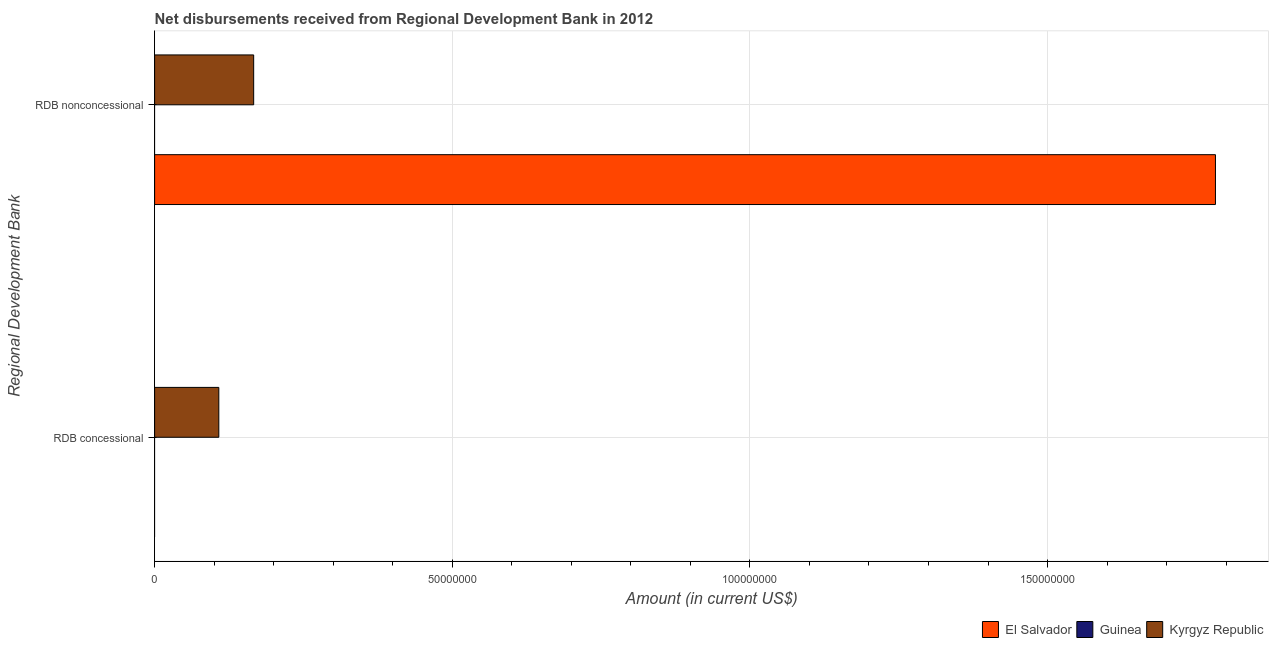How many different coloured bars are there?
Make the answer very short. 2. How many bars are there on the 1st tick from the bottom?
Offer a terse response. 1. What is the label of the 1st group of bars from the top?
Offer a very short reply. RDB nonconcessional. What is the net concessional disbursements from rdb in Kyrgyz Republic?
Ensure brevity in your answer.  1.08e+07. Across all countries, what is the maximum net concessional disbursements from rdb?
Offer a terse response. 1.08e+07. Across all countries, what is the minimum net non concessional disbursements from rdb?
Provide a succinct answer. 0. In which country was the net concessional disbursements from rdb maximum?
Offer a very short reply. Kyrgyz Republic. What is the total net concessional disbursements from rdb in the graph?
Your answer should be compact. 1.08e+07. What is the difference between the net non concessional disbursements from rdb in Kyrgyz Republic and that in El Salvador?
Keep it short and to the point. -1.62e+08. What is the difference between the net concessional disbursements from rdb in Kyrgyz Republic and the net non concessional disbursements from rdb in Guinea?
Keep it short and to the point. 1.08e+07. What is the average net concessional disbursements from rdb per country?
Make the answer very short. 3.60e+06. What is the difference between the net concessional disbursements from rdb and net non concessional disbursements from rdb in Kyrgyz Republic?
Offer a terse response. -5.86e+06. In how many countries, is the net concessional disbursements from rdb greater than 40000000 US$?
Provide a succinct answer. 0. What is the ratio of the net non concessional disbursements from rdb in Kyrgyz Republic to that in El Salvador?
Ensure brevity in your answer.  0.09. How many countries are there in the graph?
Your response must be concise. 3. Are the values on the major ticks of X-axis written in scientific E-notation?
Give a very brief answer. No. How many legend labels are there?
Your answer should be very brief. 3. What is the title of the graph?
Provide a short and direct response. Net disbursements received from Regional Development Bank in 2012. What is the label or title of the X-axis?
Ensure brevity in your answer.  Amount (in current US$). What is the label or title of the Y-axis?
Offer a very short reply. Regional Development Bank. What is the Amount (in current US$) in El Salvador in RDB concessional?
Keep it short and to the point. 0. What is the Amount (in current US$) in Kyrgyz Republic in RDB concessional?
Your answer should be very brief. 1.08e+07. What is the Amount (in current US$) in El Salvador in RDB nonconcessional?
Provide a succinct answer. 1.78e+08. What is the Amount (in current US$) in Kyrgyz Republic in RDB nonconcessional?
Offer a terse response. 1.66e+07. Across all Regional Development Bank, what is the maximum Amount (in current US$) of El Salvador?
Give a very brief answer. 1.78e+08. Across all Regional Development Bank, what is the maximum Amount (in current US$) of Kyrgyz Republic?
Your response must be concise. 1.66e+07. Across all Regional Development Bank, what is the minimum Amount (in current US$) in El Salvador?
Offer a very short reply. 0. Across all Regional Development Bank, what is the minimum Amount (in current US$) in Kyrgyz Republic?
Your response must be concise. 1.08e+07. What is the total Amount (in current US$) of El Salvador in the graph?
Offer a terse response. 1.78e+08. What is the total Amount (in current US$) in Guinea in the graph?
Provide a short and direct response. 0. What is the total Amount (in current US$) in Kyrgyz Republic in the graph?
Ensure brevity in your answer.  2.74e+07. What is the difference between the Amount (in current US$) in Kyrgyz Republic in RDB concessional and that in RDB nonconcessional?
Your response must be concise. -5.86e+06. What is the average Amount (in current US$) in El Salvador per Regional Development Bank?
Keep it short and to the point. 8.91e+07. What is the average Amount (in current US$) of Guinea per Regional Development Bank?
Your response must be concise. 0. What is the average Amount (in current US$) of Kyrgyz Republic per Regional Development Bank?
Keep it short and to the point. 1.37e+07. What is the difference between the Amount (in current US$) of El Salvador and Amount (in current US$) of Kyrgyz Republic in RDB nonconcessional?
Provide a short and direct response. 1.62e+08. What is the ratio of the Amount (in current US$) of Kyrgyz Republic in RDB concessional to that in RDB nonconcessional?
Provide a succinct answer. 0.65. What is the difference between the highest and the second highest Amount (in current US$) of Kyrgyz Republic?
Offer a terse response. 5.86e+06. What is the difference between the highest and the lowest Amount (in current US$) of El Salvador?
Make the answer very short. 1.78e+08. What is the difference between the highest and the lowest Amount (in current US$) of Kyrgyz Republic?
Offer a very short reply. 5.86e+06. 